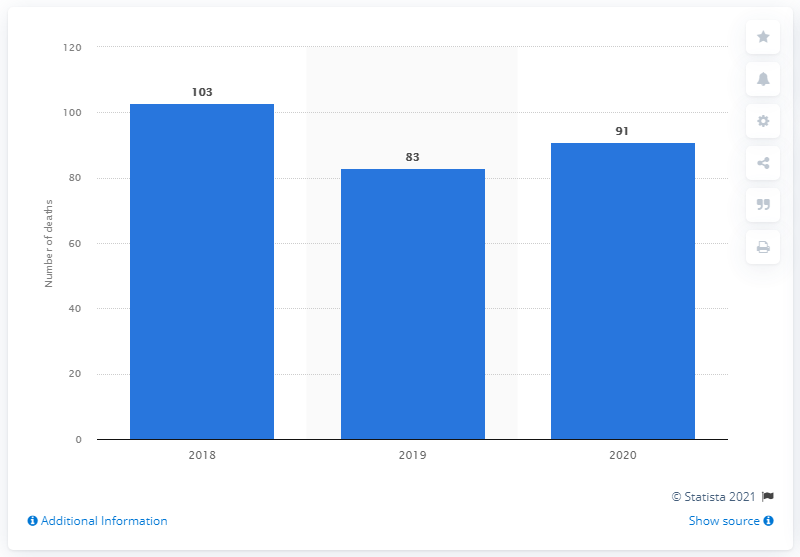Specify some key components in this picture. During the Carnival holidays in 2020, a total of 91 people died in road traffic accidents. 